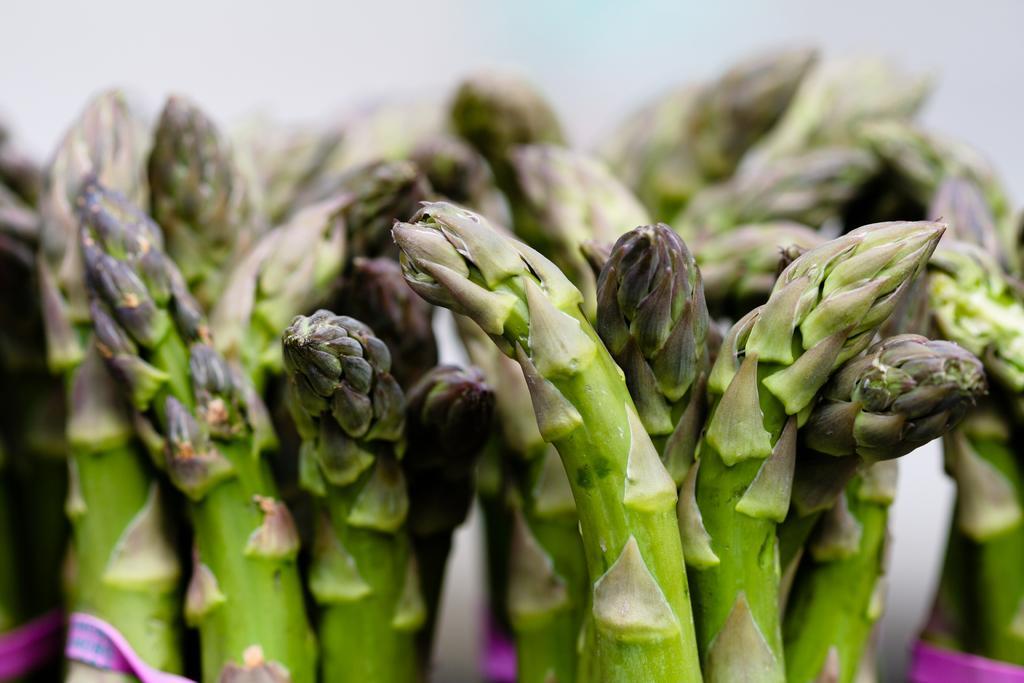Please provide a concise description of this image. In this picture we can see plants, here we can see a cloth and in the background we can see it is blurry. 